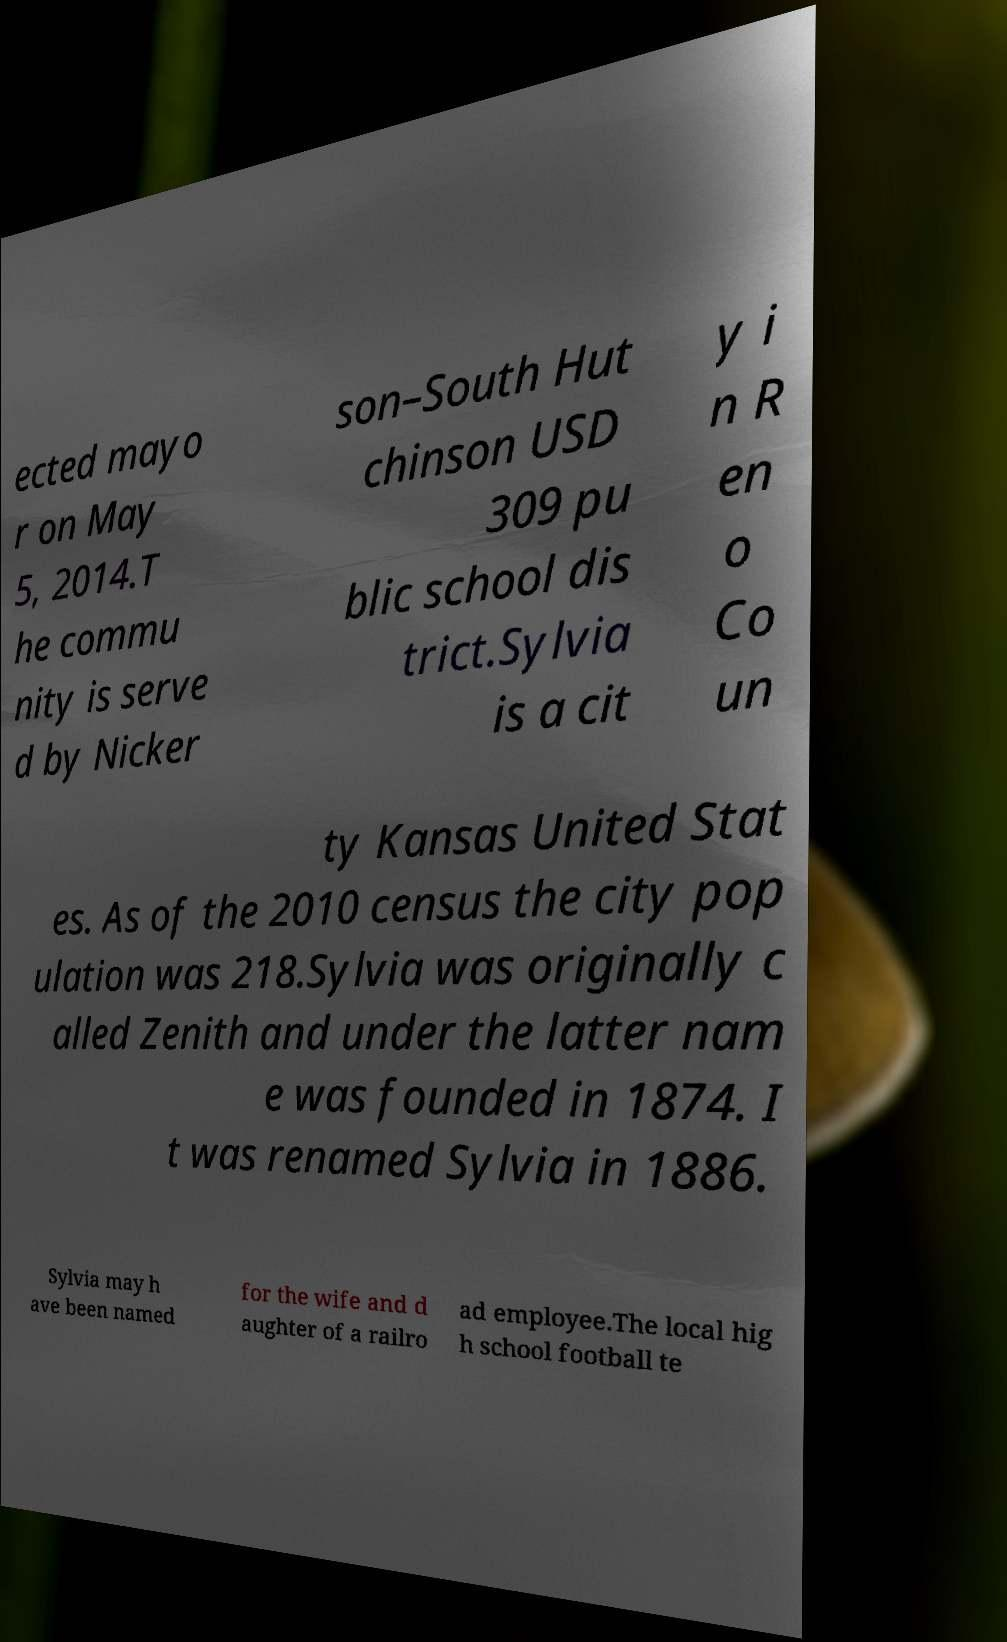Please identify and transcribe the text found in this image. ected mayo r on May 5, 2014.T he commu nity is serve d by Nicker son–South Hut chinson USD 309 pu blic school dis trict.Sylvia is a cit y i n R en o Co un ty Kansas United Stat es. As of the 2010 census the city pop ulation was 218.Sylvia was originally c alled Zenith and under the latter nam e was founded in 1874. I t was renamed Sylvia in 1886. Sylvia may h ave been named for the wife and d aughter of a railro ad employee.The local hig h school football te 